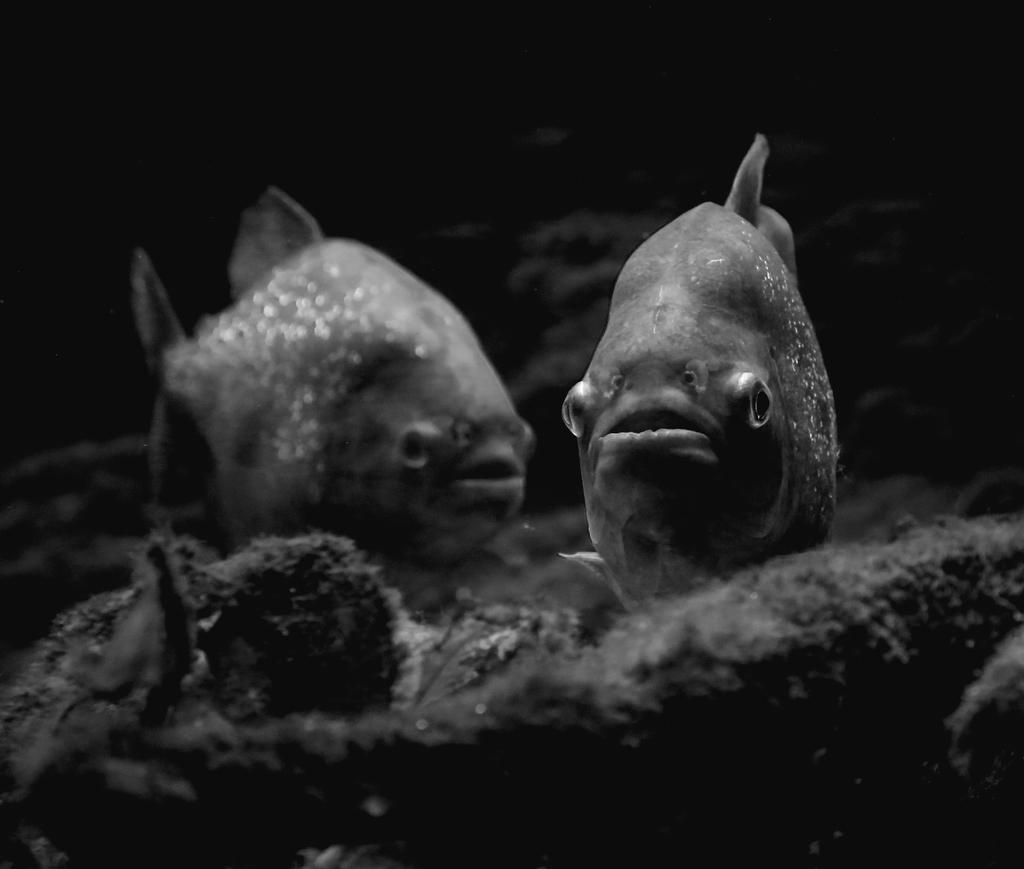What animals are present in the image? There are two fishes in the image. What color is the background of the image? The background of the image is black. What type of environment is depicted at the bottom of the image? There is a land at the bottom of the image. What type of wrist support is visible in the image? There is no wrist support present in the image. How many times does the fish lift its tail in the image? The image does not depict any action of the fish lifting its tail. 